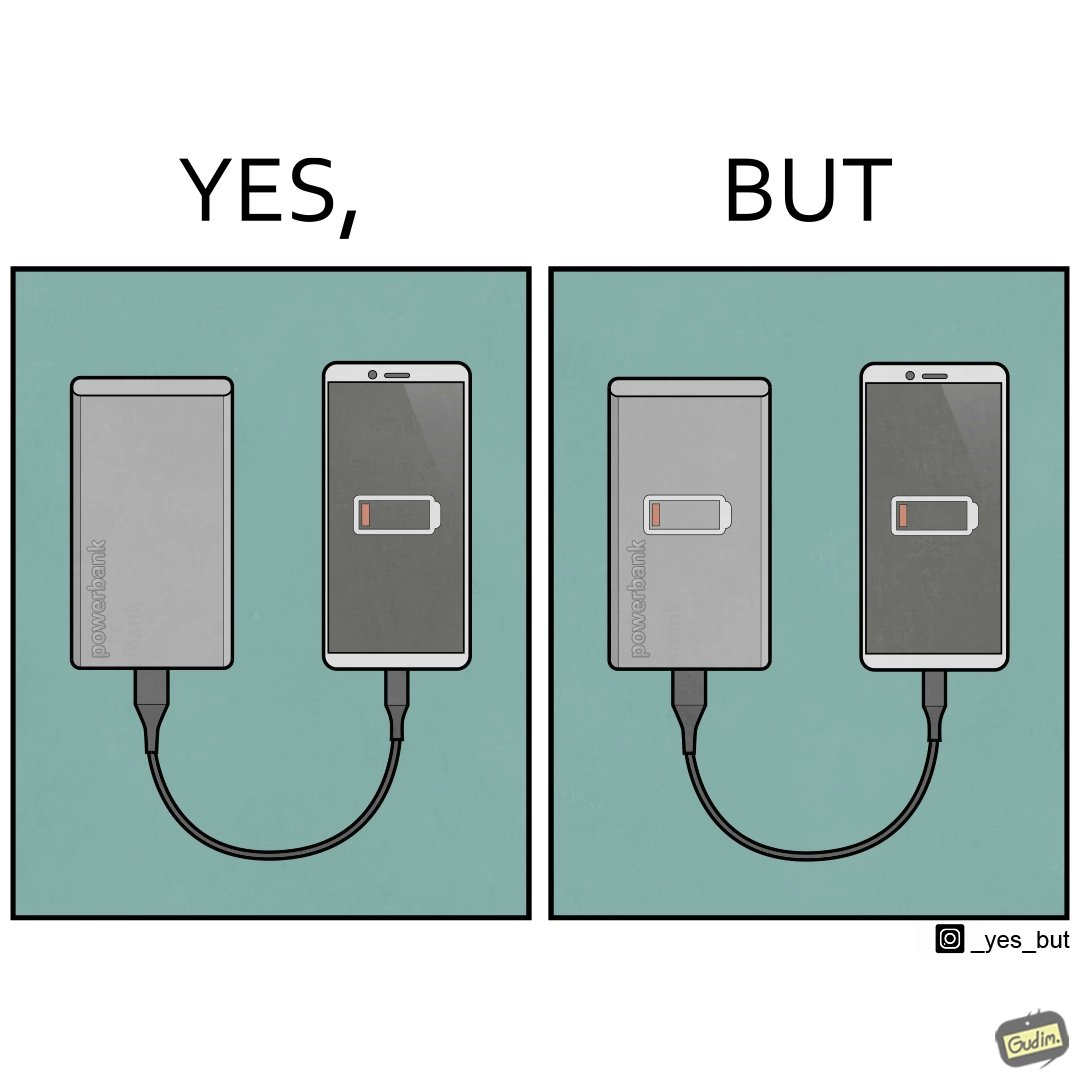Is there satirical content in this image? Yes, this image is satirical. 